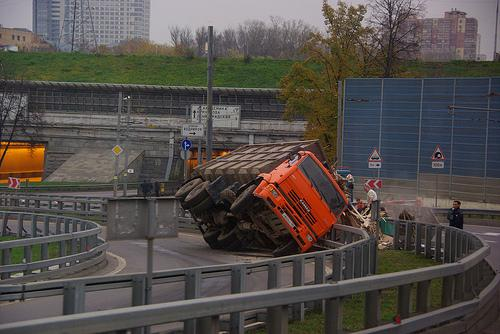Express the overall sentiment or emotion conveyed by the image. The image conveys a sense of urgency and concern due to the accident involving the overturned truck. Assess the quality and clarity of the photograph. The photo is quite clear, with a range of objects and subjects visible in detail. Mention the presence of any structures, buildings, or other objects in the photograph. There are buildings, an underpass tunnel, guard rails, three metal railings, and numerous road signs in the photo. What type of vegetation can be seen in the image? Green grass and a tree with leaves can be seen in the image. Count the number of wheels visible on the overturned truck. There are 10 visible wheels on the overturned truck. Explain the notable event occurring in the image. An orange and brown truck has overturned, causing an accident on the roadway and resulting in workers cleaning the scene. What kind of environment is the photo taken in, and what is the general condition of the objects? The photo was taken outside during the day in an area with green grass, guard rails, and many road signs. There is an overturned truck on its side. Analyze the interaction between the objects in the image, particularly focusing on the truck and the surrounding environment. The truck has fallen on its side onto the grass between the guard rails, with its wheels off the ground. The surrounding environment is full of road signs and rails, indicating a potentially dangerous road situation. The presence of workers cleaning up the accident implies that the interaction between the truck and the environment has drawn attention and necessitates intervention. Describe the condition of the road and the presence of any warning signs. The road is gray with white lines, and there are two black arrows, a blue and white arrow sign, a white and yellow triangle sign, and a sharp turn warning sign. Identify the primary object in the picture and its color. The primary object is an orange truck that has overturned. What color is the fence? The fence is grey in color. Describe the main object in the picture. An orange truck on its side. What is the sentiment associated with the image? Negative, as it depicts an accident. Are there four wheels visible on the truck? One caption specifies that the truck has 10 wheels, implying that there are more wheels than just four. What color is the road in the image? The road is grey. Identify the location of the buildings in the photo. X:25 Y:3 Width:177 Height:177 State the color of the arrow board. The arrow board is white and red. How many triangle signs are in the photo? There are two triangle signs. Does the picture show a truck standing upright? Several captions mention that the truck is on its side, overturned or its wheels are off the ground, indicating that it is not standing upright. What is the state of the vegetation in the image? The grass is green and there are trees with leaves. How many wheels does the truck have? The truck has 10 wheels. Choose the correct caption: (a) The truck is blue, (b) The truck is orange and brown, (c) The truck is purple. (b) The truck is orange and brown. Is the photo taken at night? Captions describe the photo as being taken during the day and being a daytime picture, implying it is not taken at night. What is the position of the person standing? X:433 Y:196 Width:42 Height:42 Is there a sign with two black arrows in the photo? If yes, provide its position. Yes, there is a sign with two black arrows. X:176 Y:104 Width:34 Height:34 Is there no vegetation in the photo? Multiple captions mention green grass and trees in the image, indicating the presence of vegetation. Determine if there is an anomaly in the image. Yes, there is a truck that has overturned. Identify different areas of the image, such as the road, grass, and buildings. Road: X:133 Y:220 Width:79 Height:79, Grass: X:258 Y:207 Width:240 Height:240, Buildings: X:25 Y:3 Width:177 Height:177 Is there an underpass tunnel in the image? Yes, there is an underpass tunnel. Identify and describe the road signs in the picture. White and yellow triangle sign, blue and white arrow sign, two black arrows, sharp turn warning sign. Is the road in the image color purple? The captions describe the road as being grey, not purple. Evaluate the quality of the photo. Clear and well-taken. Find any objects interacting with the truck. Workers are cleaning up the accident. Describe the condition of the truck in the image. The truck is overturned with wheels off the ground. Is the truck in the image blue?  The truck is described as being orange multiple times, not blue. 